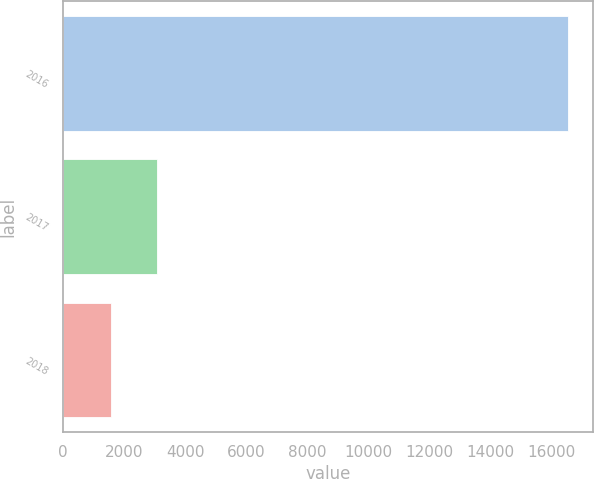Convert chart to OTSL. <chart><loc_0><loc_0><loc_500><loc_500><bar_chart><fcel>2016<fcel>2017<fcel>2018<nl><fcel>16528<fcel>3064<fcel>1568<nl></chart> 